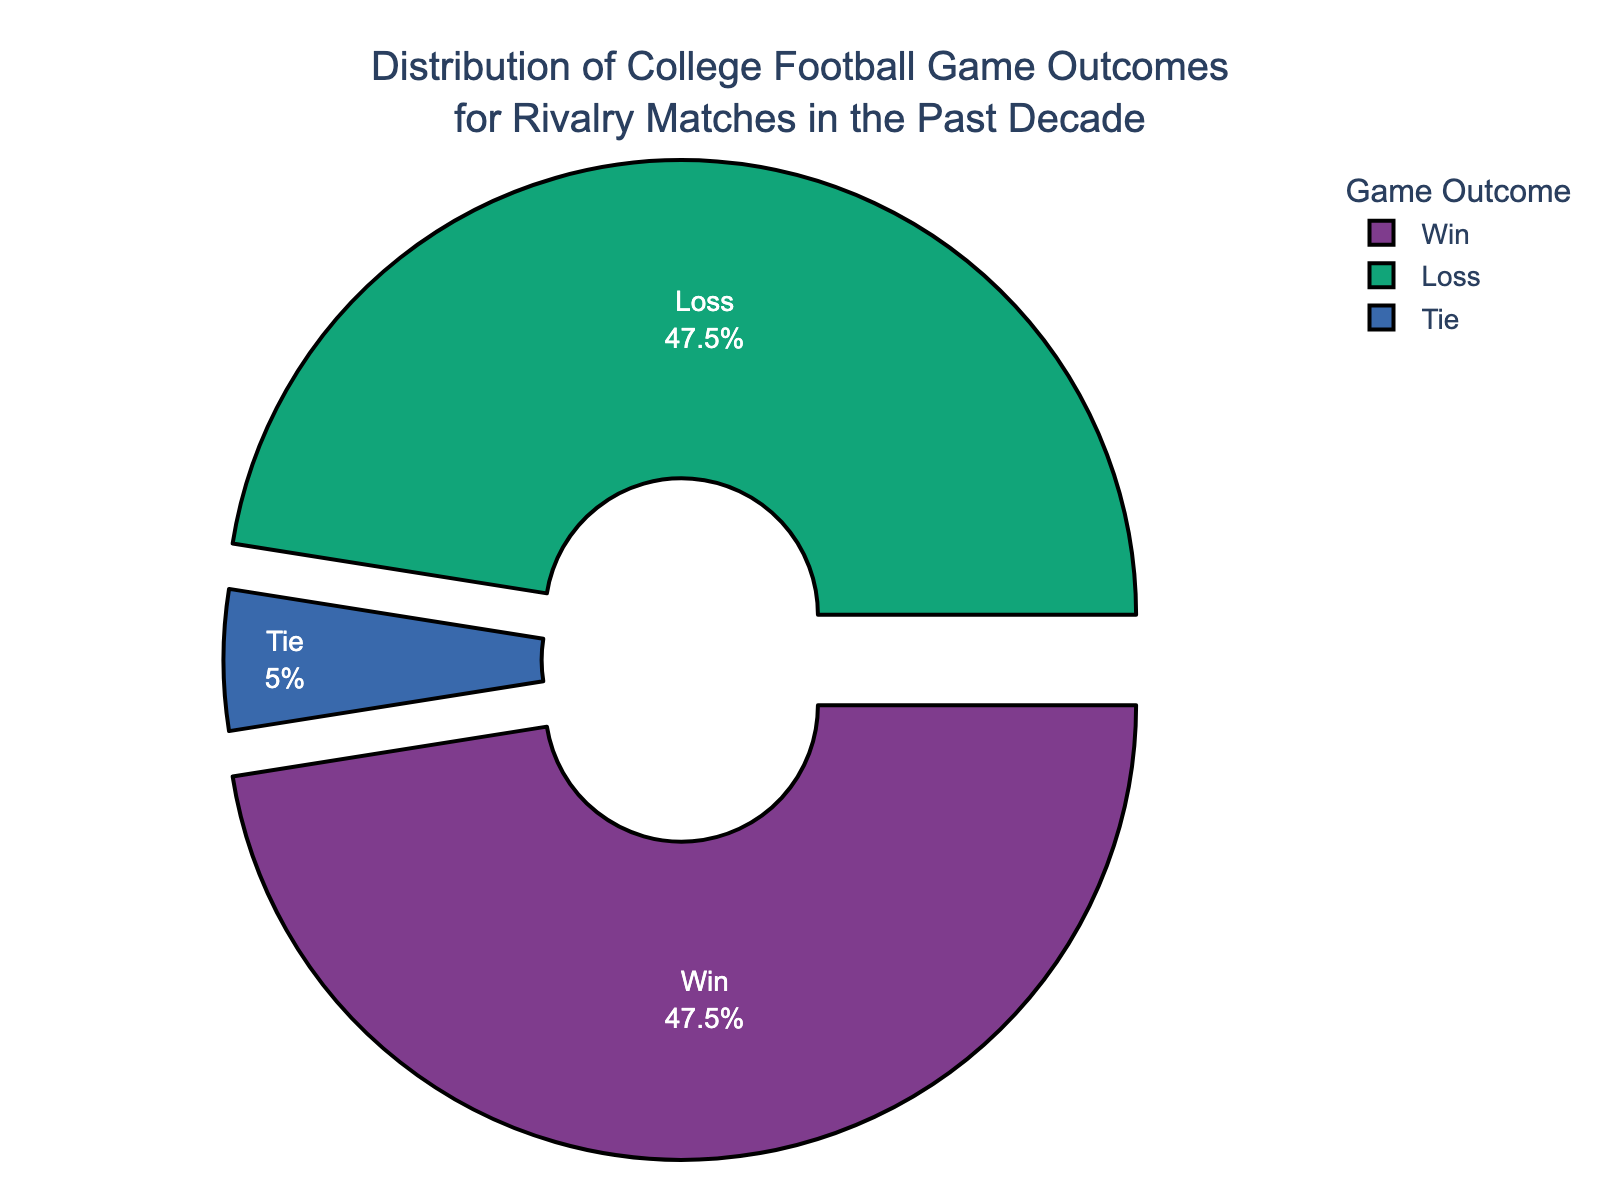What's the percentage of games that ended in a tie? The pie chart shows a section labeled "Tie" with the percentage inside the slice. The label indicates that 5.0% of the games ended in a tie.
Answer: 5.0% How do the percentages of wins and losses compare to each other? The pie chart shows two sections labeled "Win" and "Loss," each with the same percentage. Both sections show a percentage of 47.5%, meaning wins and losses occurred equally.
Answer: They are equal What is the total percentage of games that did not end in a tie? To find the total percentage of games that did not end in a tie, add the percentages of wins and losses. That is 47.5% (wins) + 47.5% (losses) = 95.0%.
Answer: 95.0% Which outcome has the smallest percentage? The pie chart shows three sections, each labeled with "Win," "Loss," and "Tie." The "Tie" section has the smallest percentage at 5.0%.
Answer: Tie What is the difference in percentage between the most frequent outcome and the least frequent outcome? The most frequent outcomes are wins and losses, each at 47.5%, and the least frequent outcome is a tie at 5.0%. The difference is 47.5% - 5.0% = 42.5%.
Answer: 42.5% What is the combined percentage of wins and ties? To find the combined percentage of wins and ties, add their respective percentages. That is 47.5% (wins) + 5.0% (ties) = 52.5%.
Answer: 52.5% If the chart were rotated 90 degrees clockwise, which outcome section would appear at the top? The current pie chart is rotated such that looking at it, wins and losses are equally offset while the tie is not. Rotating the chart 90 degrees clockwise, the section for "Tie" would appear at the top.
Answer: Tie Which section is highlighted (pulled out) somewhat, and why might that be? In the pie chart, the sections for "Win" and "Loss" are pulled out, while the "Tie" section is not. This could be a visual emphasis to show the equal importance or frequency of wins and losses compared to ties.
Answer: Win and Loss 